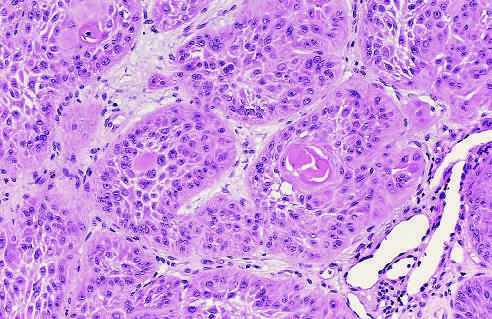re skin stem cells strikingly similar to normal squamous epithelial cells, with intercellular bridges and nests of keratin?
Answer the question using a single word or phrase. No 